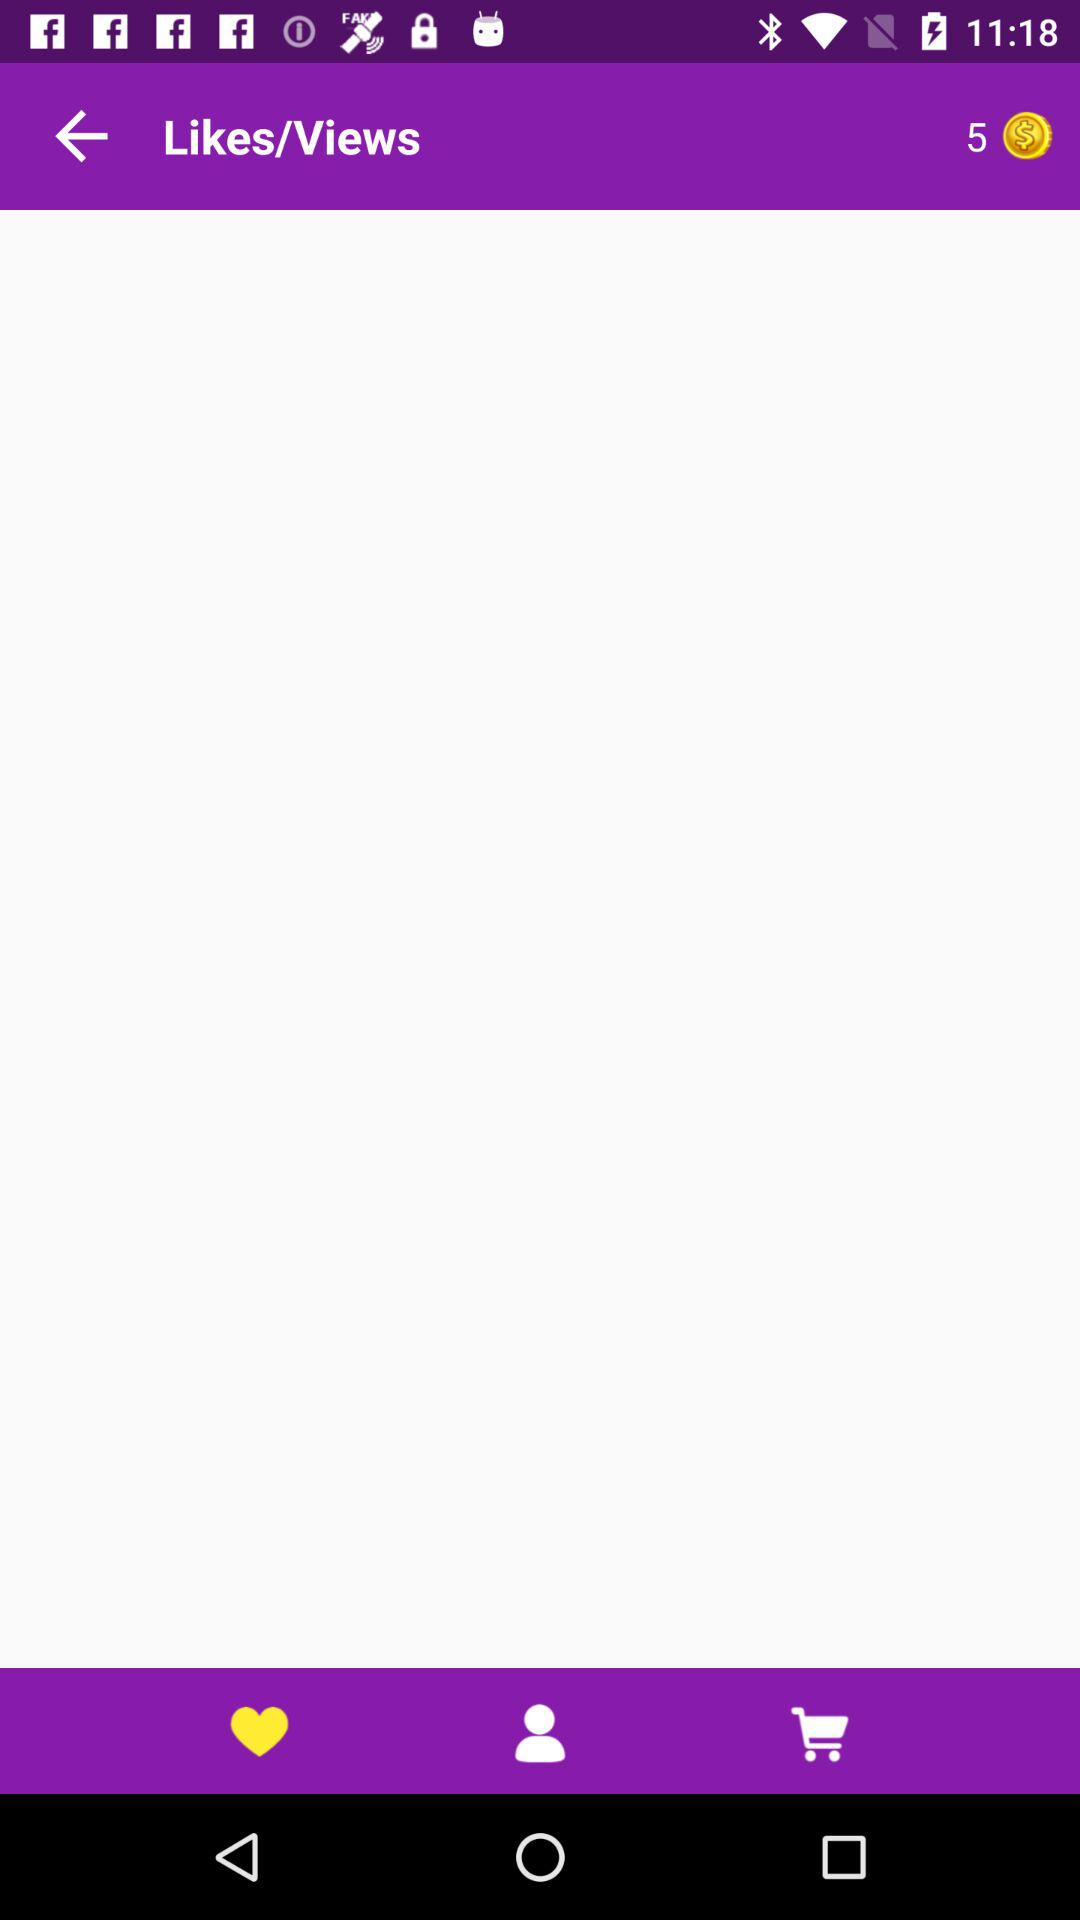What is the count of coins showing in the application? The count of coins is 5. 